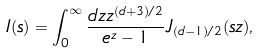Convert formula to latex. <formula><loc_0><loc_0><loc_500><loc_500>I ( s ) = \int _ { 0 } ^ { \infty } \frac { d z z ^ { ( d + 3 ) / 2 } } { e ^ { z } - 1 } J _ { ( d - 1 ) / 2 } ( s z ) ,</formula> 